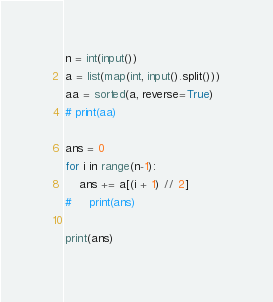<code> <loc_0><loc_0><loc_500><loc_500><_Python_>n = int(input())
a = list(map(int, input().split()))
aa = sorted(a, reverse=True)
# print(aa)

ans = 0
for i in range(n-1):
    ans += a[(i + 1) // 2]
#     print(ans)

print(ans)
</code> 